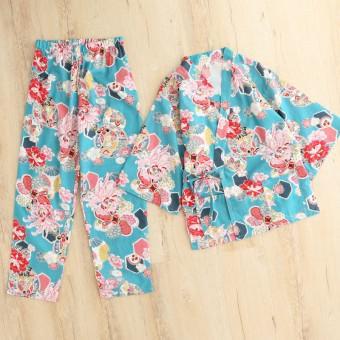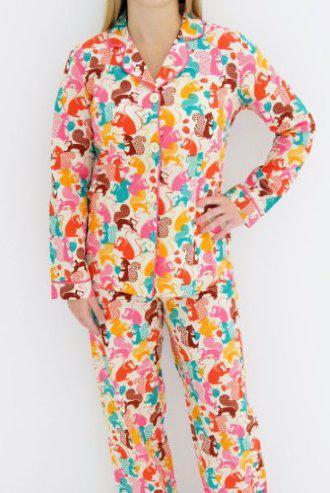The first image is the image on the left, the second image is the image on the right. For the images displayed, is the sentence "Each image contains one outfit consisting of printed pajama pants and a coordinating top featuring the same printed pattern." factually correct? Answer yes or no. Yes. 